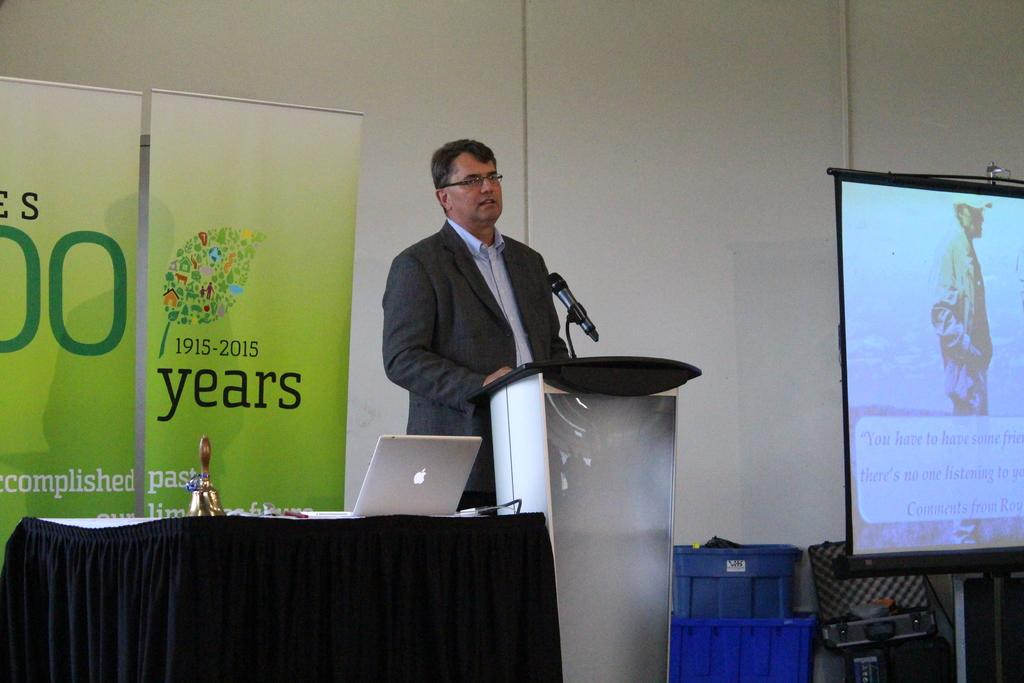<image>
Offer a succinct explanation of the picture presented. A man stands at a podium in front of a green banner that says 1915-2015 under a picture of a leaf. 